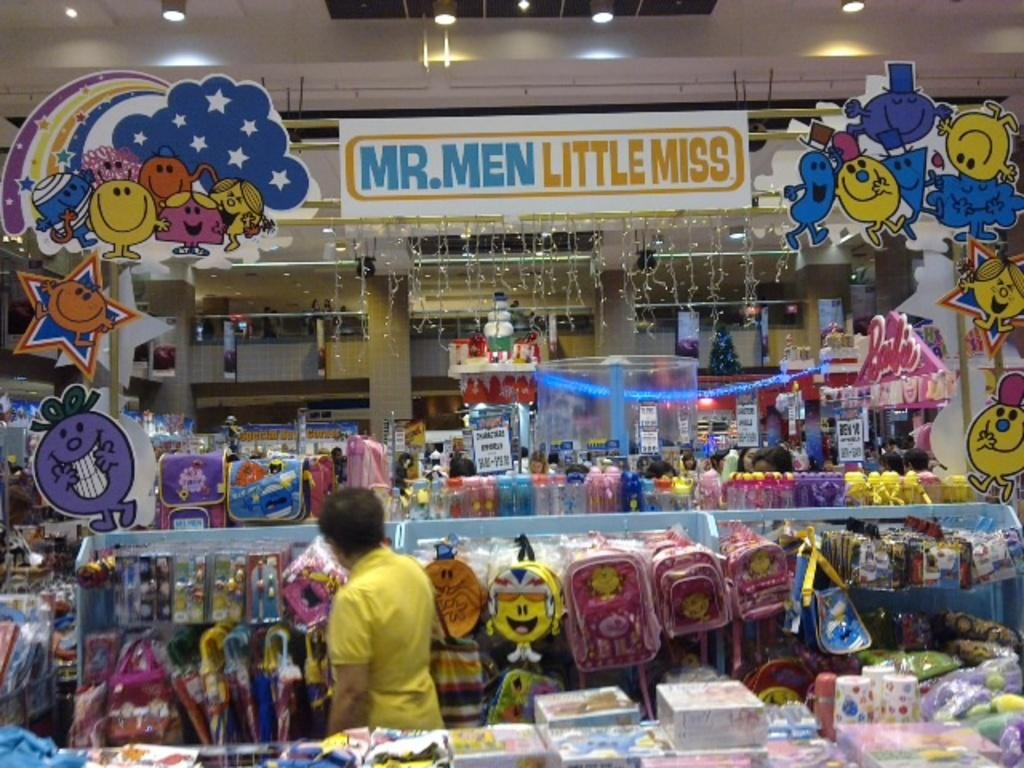<image>
Render a clear and concise summary of the photo. MR MEN LITTLE MISS STORE ISLE DISPLAY WITH TOYS 